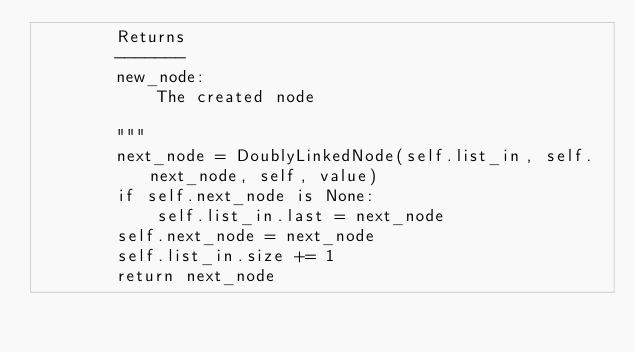Convert code to text. <code><loc_0><loc_0><loc_500><loc_500><_Python_>        Returns
        -------
        new_node:
            The created node

        """
        next_node = DoublyLinkedNode(self.list_in, self.next_node, self, value)
        if self.next_node is None:
            self.list_in.last = next_node
        self.next_node = next_node
        self.list_in.size += 1
        return next_node
</code> 